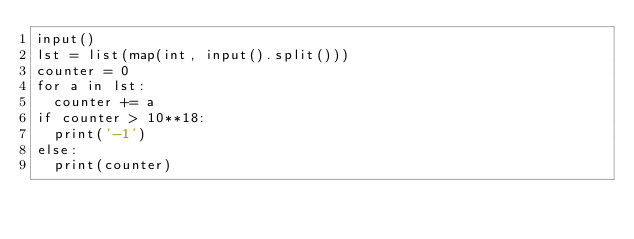<code> <loc_0><loc_0><loc_500><loc_500><_Python_>input()
lst = list(map(int, input().split()))
counter = 0
for a in lst:
  counter += a
if counter > 10**18:
  print('-1')
else:
  print(counter)</code> 